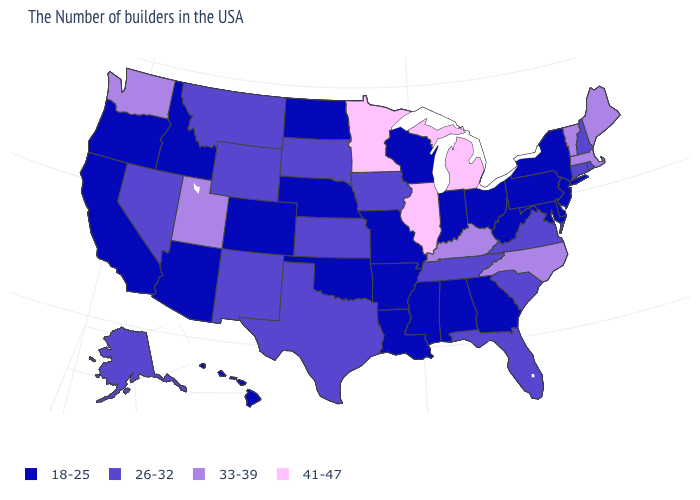What is the value of North Carolina?
Short answer required. 33-39. Is the legend a continuous bar?
Write a very short answer. No. Does Delaware have a lower value than Virginia?
Keep it brief. Yes. What is the value of New Hampshire?
Short answer required. 26-32. What is the highest value in the USA?
Be succinct. 41-47. Is the legend a continuous bar?
Write a very short answer. No. Name the states that have a value in the range 41-47?
Short answer required. Michigan, Illinois, Minnesota. Name the states that have a value in the range 18-25?
Answer briefly. New York, New Jersey, Delaware, Maryland, Pennsylvania, West Virginia, Ohio, Georgia, Indiana, Alabama, Wisconsin, Mississippi, Louisiana, Missouri, Arkansas, Nebraska, Oklahoma, North Dakota, Colorado, Arizona, Idaho, California, Oregon, Hawaii. Which states have the lowest value in the Northeast?
Answer briefly. New York, New Jersey, Pennsylvania. Among the states that border Utah , which have the highest value?
Quick response, please. Wyoming, New Mexico, Nevada. What is the value of West Virginia?
Quick response, please. 18-25. What is the value of Rhode Island?
Keep it brief. 26-32. Name the states that have a value in the range 18-25?
Write a very short answer. New York, New Jersey, Delaware, Maryland, Pennsylvania, West Virginia, Ohio, Georgia, Indiana, Alabama, Wisconsin, Mississippi, Louisiana, Missouri, Arkansas, Nebraska, Oklahoma, North Dakota, Colorado, Arizona, Idaho, California, Oregon, Hawaii. Is the legend a continuous bar?
Write a very short answer. No. Does Washington have the lowest value in the USA?
Quick response, please. No. 